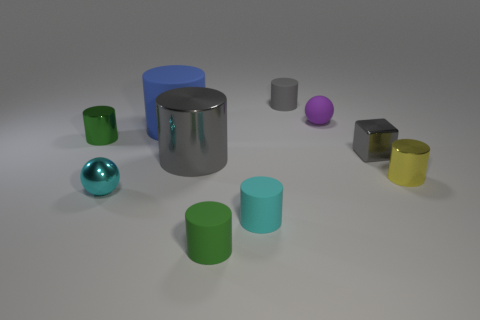Subtract 3 cylinders. How many cylinders are left? 4 Subtract all gray cylinders. How many cylinders are left? 5 Subtract all small shiny cylinders. How many cylinders are left? 5 Subtract all purple cylinders. Subtract all gray blocks. How many cylinders are left? 7 Subtract all cylinders. How many objects are left? 3 Subtract all big cylinders. Subtract all rubber spheres. How many objects are left? 7 Add 7 tiny green matte cylinders. How many tiny green matte cylinders are left? 8 Add 9 purple spheres. How many purple spheres exist? 10 Subtract 0 blue balls. How many objects are left? 10 